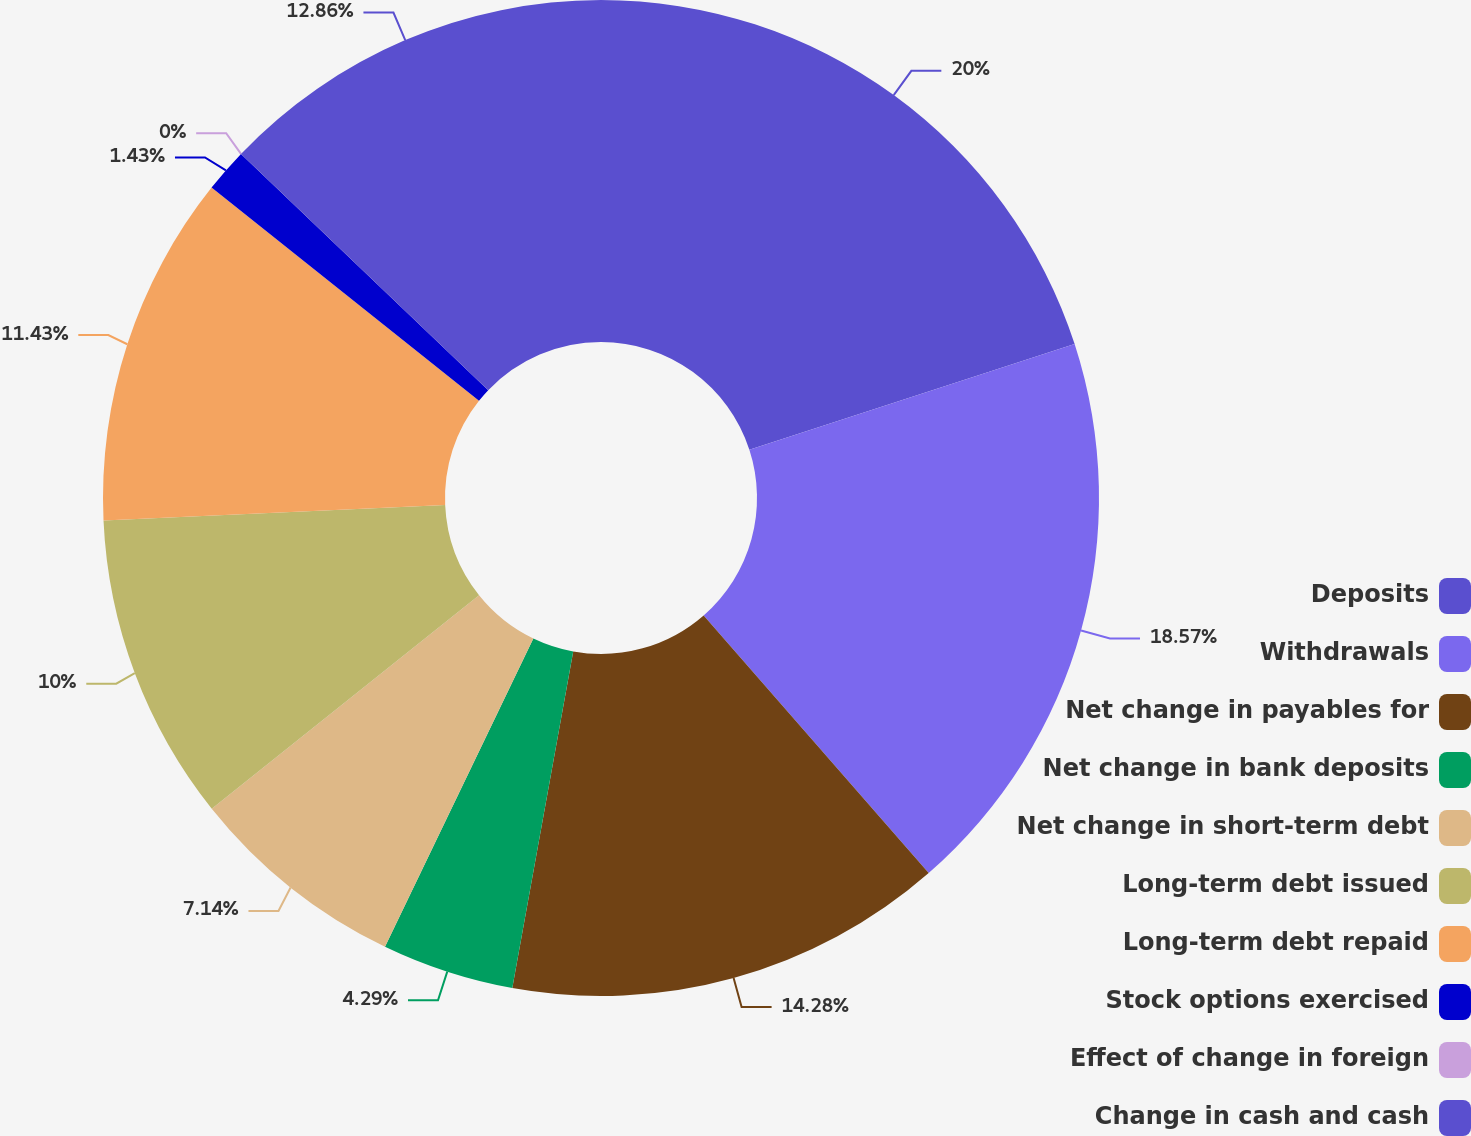Convert chart to OTSL. <chart><loc_0><loc_0><loc_500><loc_500><pie_chart><fcel>Deposits<fcel>Withdrawals<fcel>Net change in payables for<fcel>Net change in bank deposits<fcel>Net change in short-term debt<fcel>Long-term debt issued<fcel>Long-term debt repaid<fcel>Stock options exercised<fcel>Effect of change in foreign<fcel>Change in cash and cash<nl><fcel>20.0%<fcel>18.57%<fcel>14.28%<fcel>4.29%<fcel>7.14%<fcel>10.0%<fcel>11.43%<fcel>1.43%<fcel>0.0%<fcel>12.86%<nl></chart> 